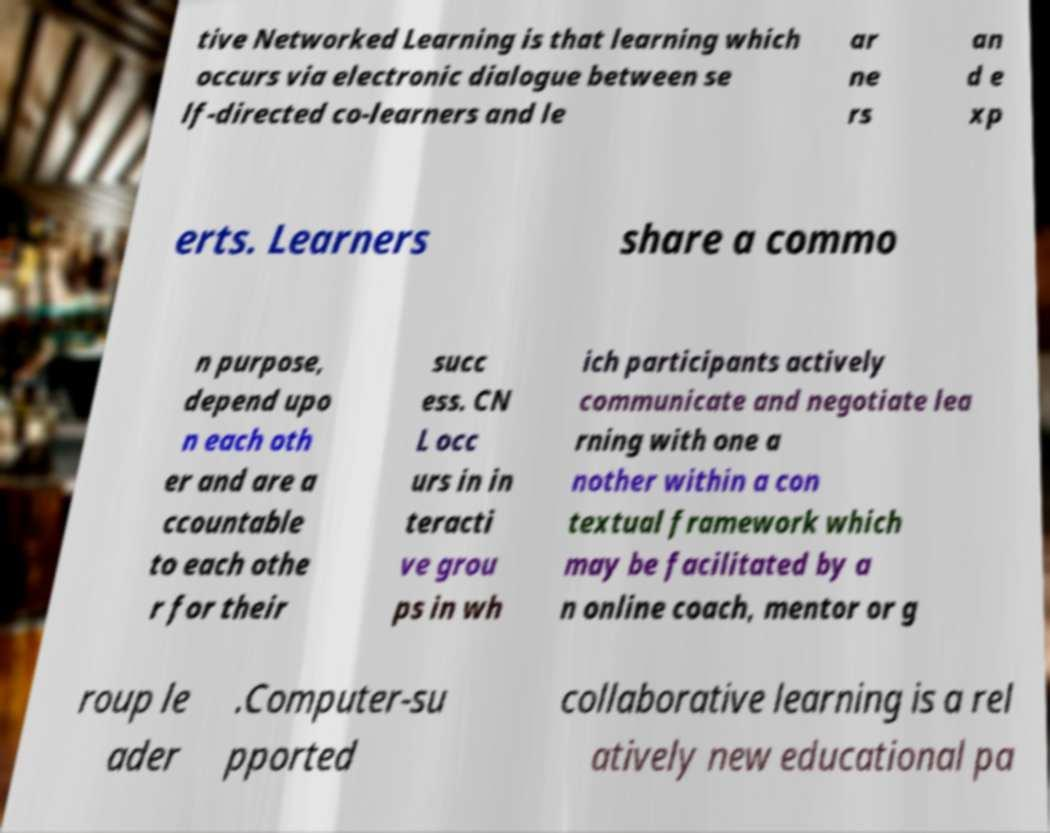Can you read and provide the text displayed in the image?This photo seems to have some interesting text. Can you extract and type it out for me? tive Networked Learning is that learning which occurs via electronic dialogue between se lf-directed co-learners and le ar ne rs an d e xp erts. Learners share a commo n purpose, depend upo n each oth er and are a ccountable to each othe r for their succ ess. CN L occ urs in in teracti ve grou ps in wh ich participants actively communicate and negotiate lea rning with one a nother within a con textual framework which may be facilitated by a n online coach, mentor or g roup le ader .Computer-su pported collaborative learning is a rel atively new educational pa 